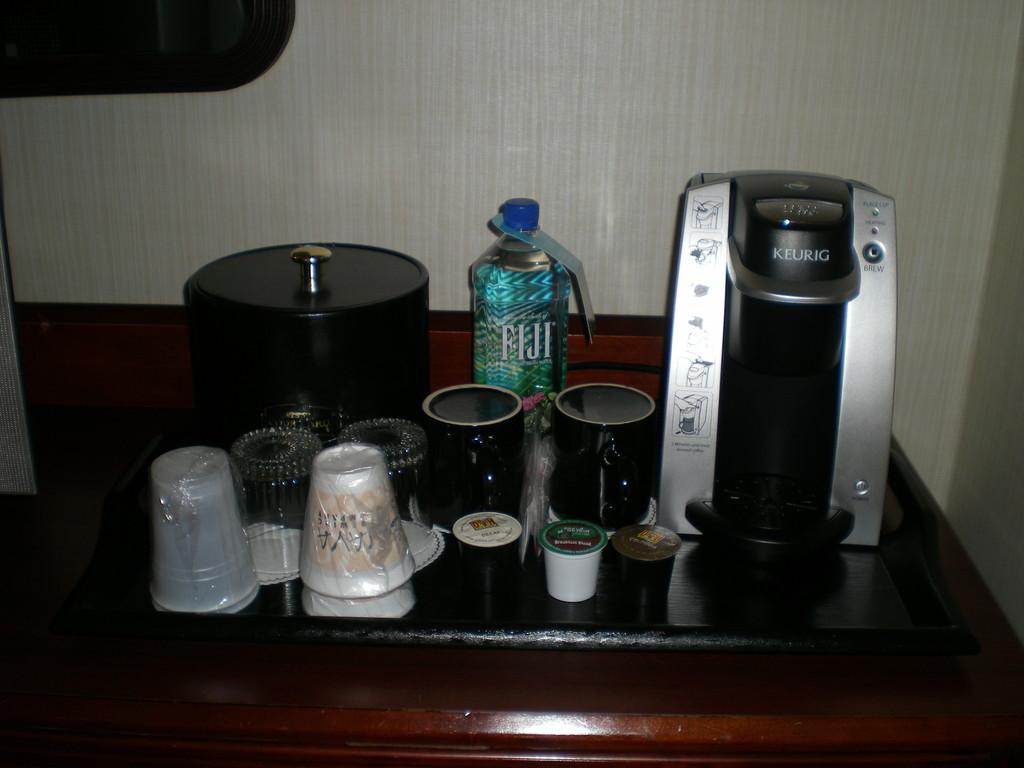<image>
Summarize the visual content of the image. a tray of drinks including a keurig coffeemaker and a bottle of fiji water 